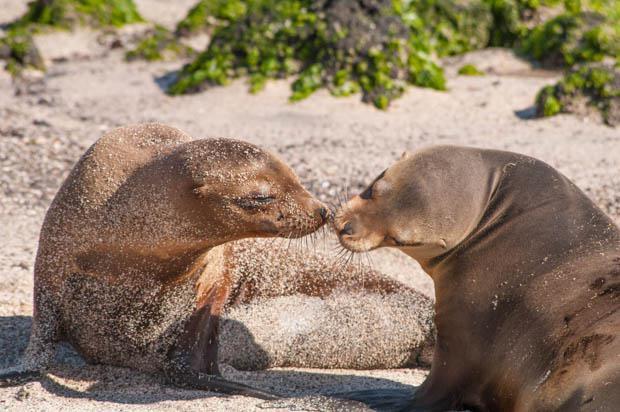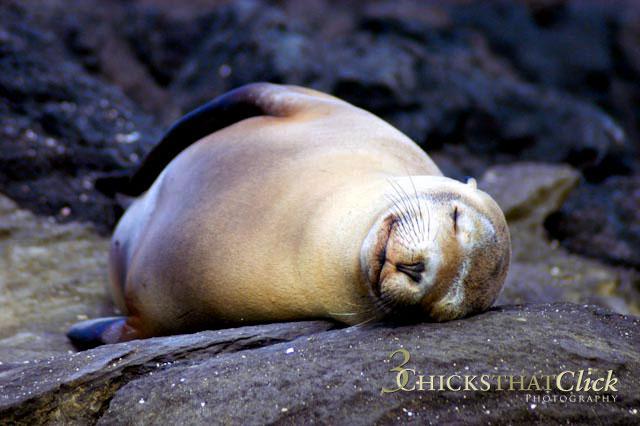The first image is the image on the left, the second image is the image on the right. Evaluate the accuracy of this statement regarding the images: "The left image contains no more than one seal.". Is it true? Answer yes or no. No. The first image is the image on the left, the second image is the image on the right. Analyze the images presented: Is the assertion "Each image includes a dark, wet seal with its head upright, and in at least one image, rocks jut out of the water." valid? Answer yes or no. No. 